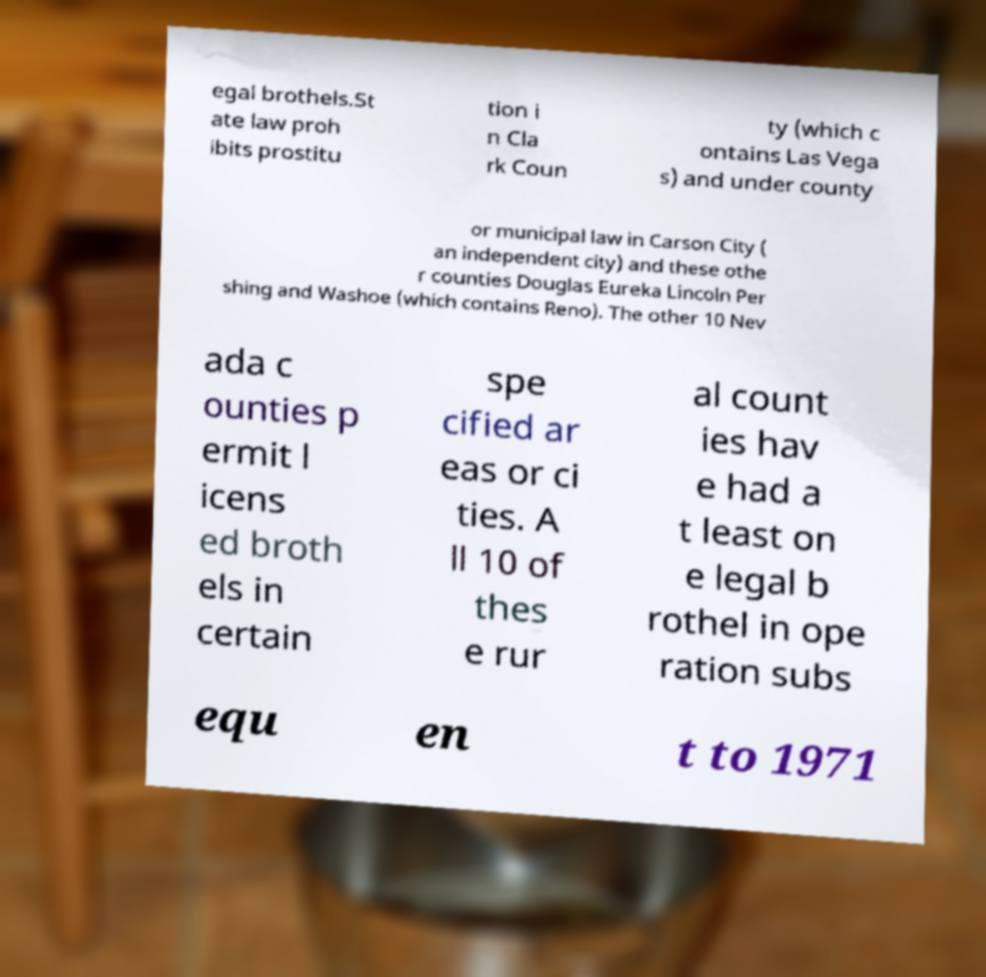There's text embedded in this image that I need extracted. Can you transcribe it verbatim? egal brothels.St ate law proh ibits prostitu tion i n Cla rk Coun ty (which c ontains Las Vega s) and under county or municipal law in Carson City ( an independent city) and these othe r counties Douglas Eureka Lincoln Per shing and Washoe (which contains Reno). The other 10 Nev ada c ounties p ermit l icens ed broth els in certain spe cified ar eas or ci ties. A ll 10 of thes e rur al count ies hav e had a t least on e legal b rothel in ope ration subs equ en t to 1971 